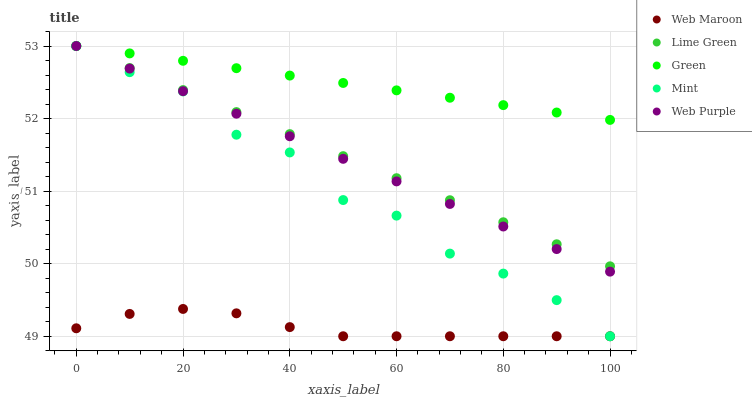Does Web Maroon have the minimum area under the curve?
Answer yes or no. Yes. Does Green have the maximum area under the curve?
Answer yes or no. Yes. Does Web Purple have the minimum area under the curve?
Answer yes or no. No. Does Web Purple have the maximum area under the curve?
Answer yes or no. No. Is Lime Green the smoothest?
Answer yes or no. Yes. Is Mint the roughest?
Answer yes or no. Yes. Is Web Purple the smoothest?
Answer yes or no. No. Is Web Purple the roughest?
Answer yes or no. No. Does Web Maroon have the lowest value?
Answer yes or no. Yes. Does Web Purple have the lowest value?
Answer yes or no. No. Does Mint have the highest value?
Answer yes or no. Yes. Does Web Maroon have the highest value?
Answer yes or no. No. Is Web Maroon less than Green?
Answer yes or no. Yes. Is Web Purple greater than Web Maroon?
Answer yes or no. Yes. Does Lime Green intersect Mint?
Answer yes or no. Yes. Is Lime Green less than Mint?
Answer yes or no. No. Is Lime Green greater than Mint?
Answer yes or no. No. Does Web Maroon intersect Green?
Answer yes or no. No. 